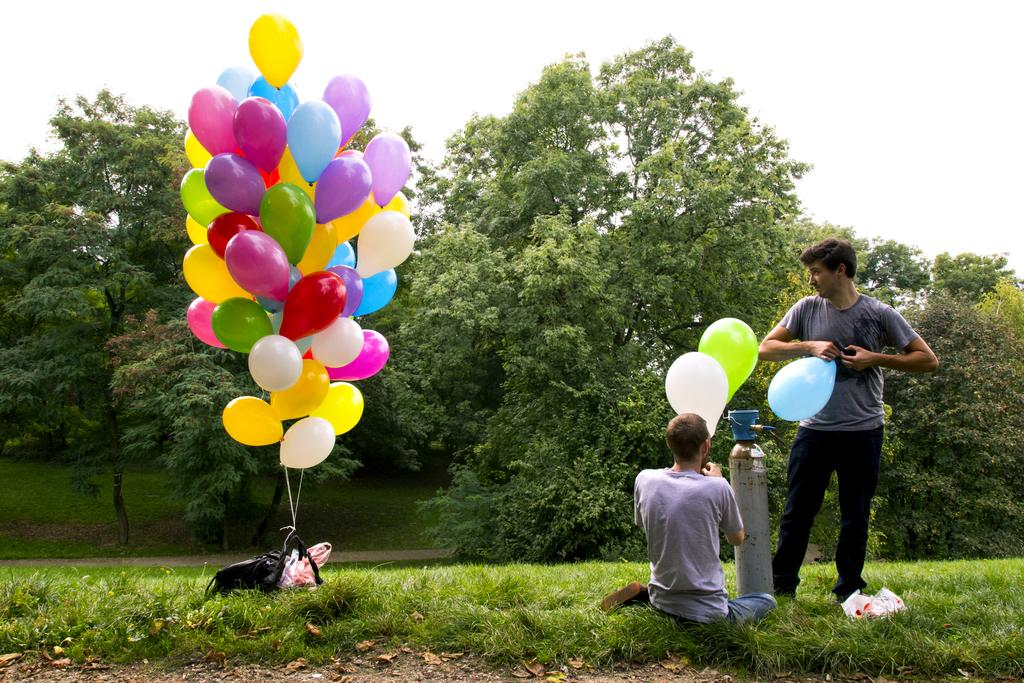How many people are in the image? There are 2 people in the image. Where are the people located in the image? The people are on the grass. What are the people holding in the image? The people are holding balloons. Can you describe the objects on the left side of the image? There is a bunch of balloons on the left side of the image. What can be seen in the background of the image? There are many trees in the background of the image. What is the income of the grandfather in the image? There is no grandfather present in the image, and therefore no information about their income can be provided. 